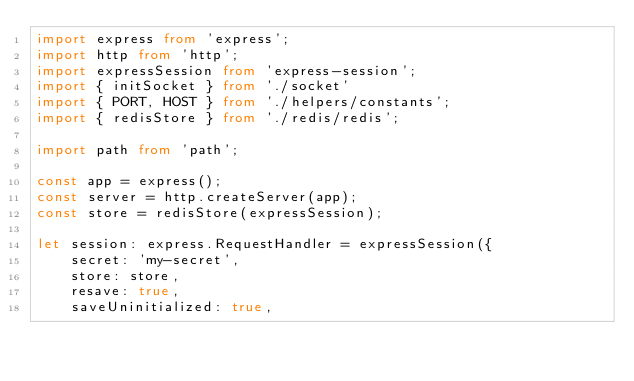Convert code to text. <code><loc_0><loc_0><loc_500><loc_500><_TypeScript_>import express from 'express';
import http from 'http';
import expressSession from 'express-session';
import { initSocket } from './socket'
import { PORT, HOST } from './helpers/constants';
import { redisStore } from './redis/redis';

import path from 'path';

const app = express();
const server = http.createServer(app);
const store = redisStore(expressSession);

let session: express.RequestHandler = expressSession({
    secret: 'my-secret',
    store: store,
    resave: true,
    saveUninitialized: true,</code> 